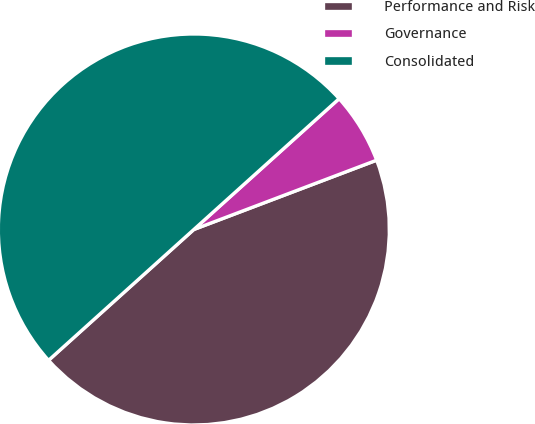Convert chart. <chart><loc_0><loc_0><loc_500><loc_500><pie_chart><fcel>Performance and Risk<fcel>Governance<fcel>Consolidated<nl><fcel>44.1%<fcel>5.9%<fcel>50.0%<nl></chart> 